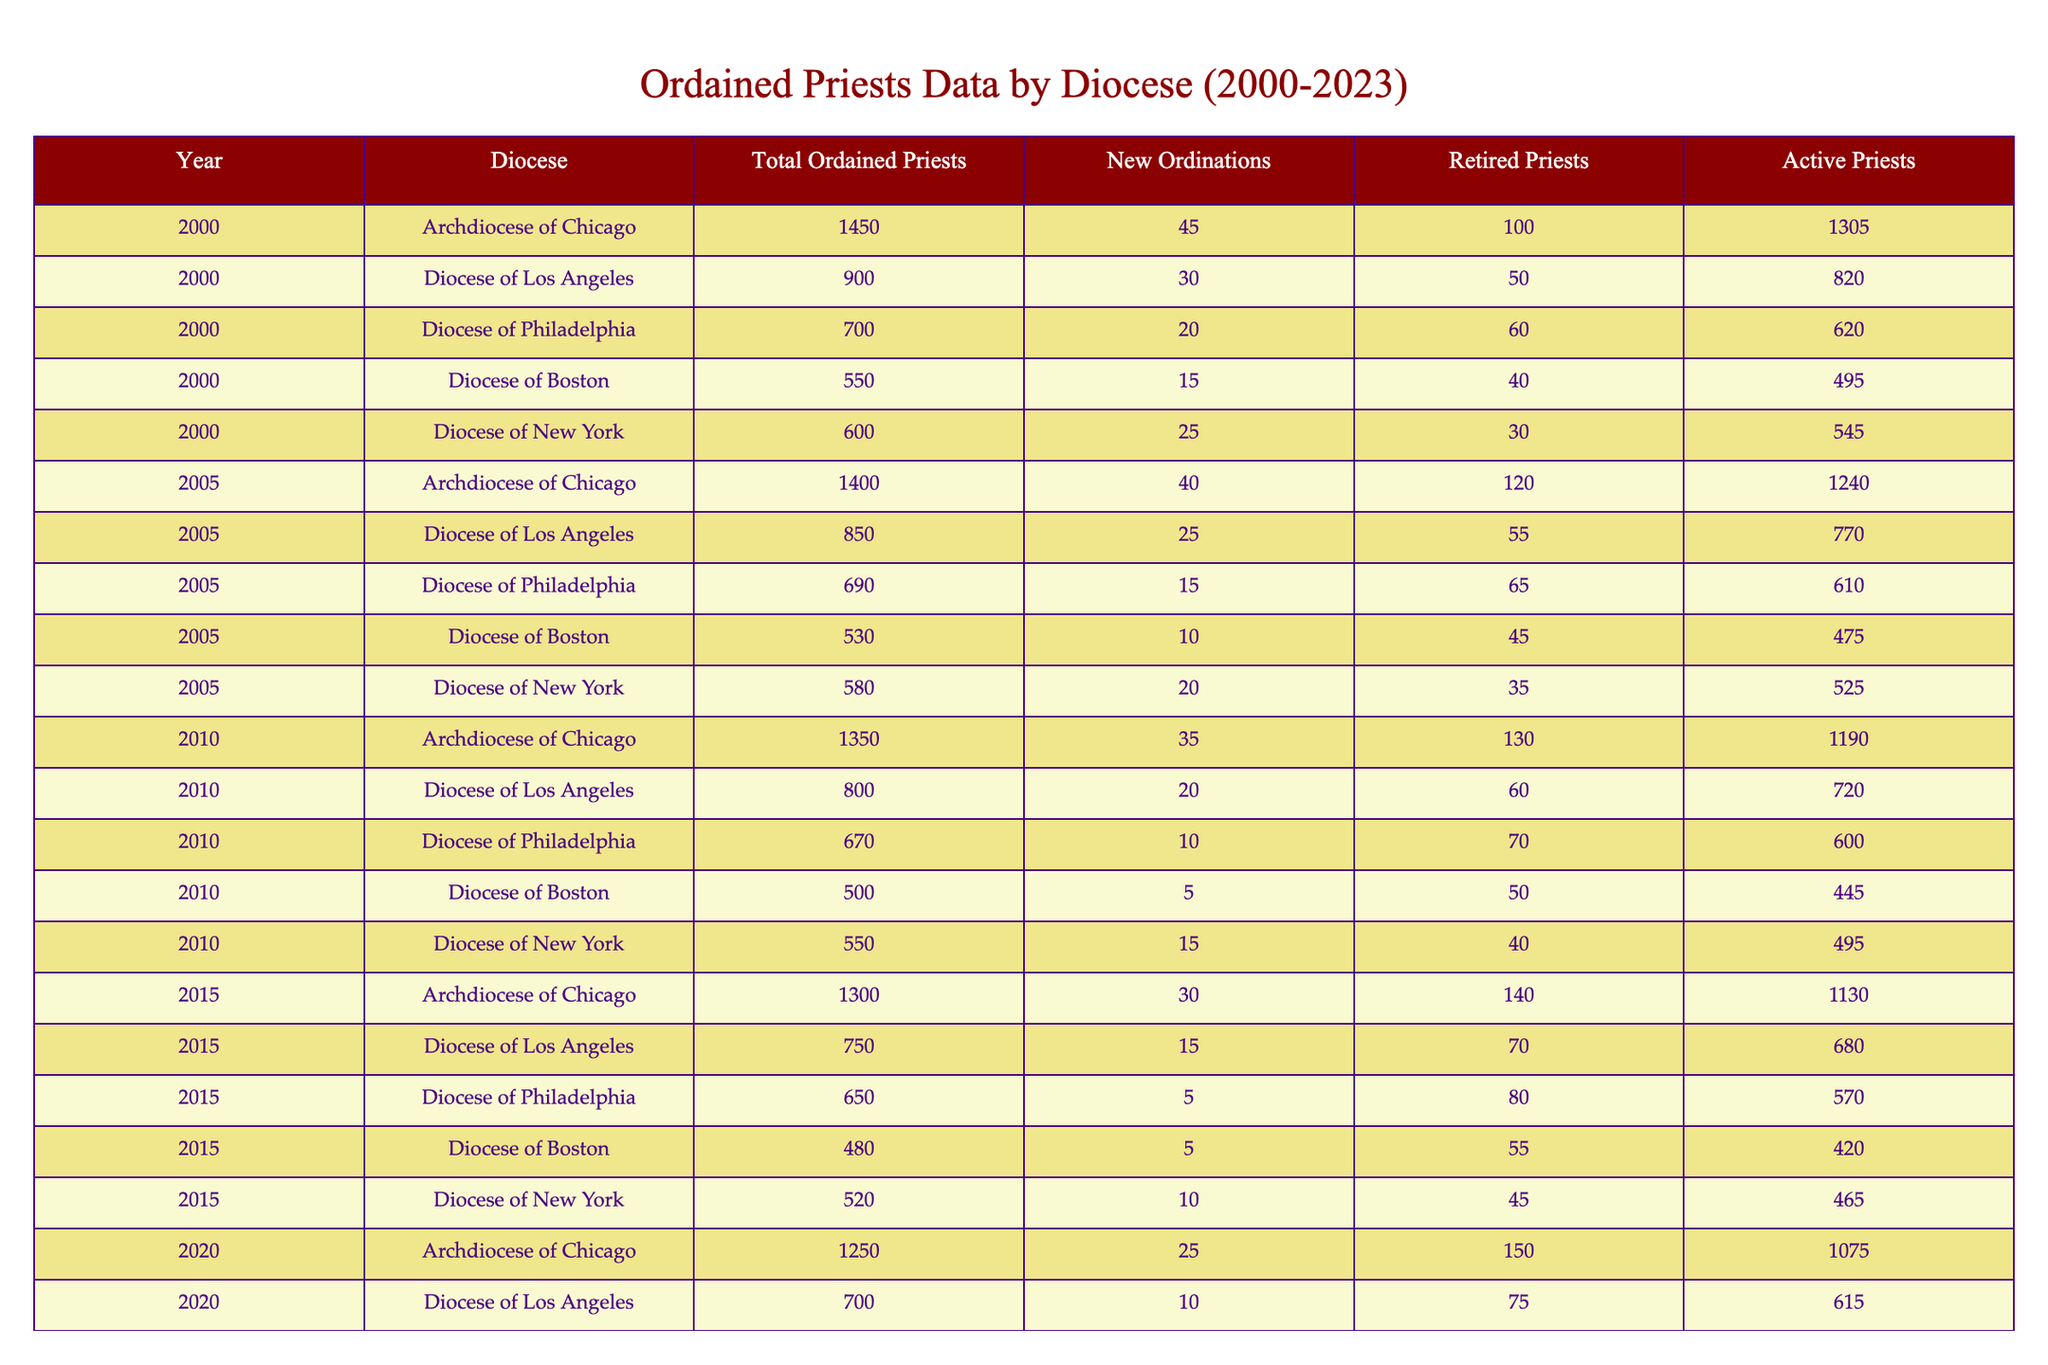What was the total number of ordained priests in the Archdiocese of Chicago in 2010? From the table, the row for the Archdiocese of Chicago in 2010 shows a value of 1350 for Total Ordained Priests.
Answer: 1350 How many new ordinations were there in the Diocese of Boston in 2023? Looking at the row for the Diocese of Boston in 2023, the value for New Ordinations is 5.
Answer: 5 Which diocese had the highest number of active priests in 2005? In 2005, the Archdiocese of Chicago had 1240 active priests, which is higher than any other diocese listed for that year.
Answer: Archdiocese of Chicago How many total ordained priests were there in the Diocese of Philadelphia by 2020? The data shows that the number of Total Ordained Priests in the Diocese of Philadelphia in 2020 was 620.
Answer: 620 What is the average number of new ordinations across all dioceses in 2015? Adding up the new ordinations for all dioceses in 2015 gives: 30 + 15 + 5 + 5 + 10 = 65. Dividing this sum by 5 (the number of dioceses) results in an average of 13.
Answer: 13 Did the number of active priests in the Diocese of New York increase from 2020 to 2023? In 2020, there were 445 active priests in the Diocese of New York, and in 2023, that number rose to 480. Therefore, the number increased.
Answer: Yes What was the total decrease in the number of ordained priests in the Archdiocese of Chicago from 2000 to 2023? The data shows that the total number of ordained priests in 2000 was 1450, and by 2023 it was 1200. The decrease is 1450 - 1200 = 250.
Answer: 250 Which diocese experienced the largest decrease in the number of total ordained priests from 2000 to 2023? By comparing the values, the Diocese of Boston decreased from 550 to 440, resulting in a decrease of 110. The Diocese of Los Angeles decreased from 900 to 650, a drop of 250, indicating it experienced the largest decrease.
Answer: Diocese of Los Angeles What percentage of priests were retired in the Diocese of Philadelphia in 2010? In 2010, the Diocese of Philadelphia had 670 ordained priests and 70 were retired. The percentage is (70 / 670) * 100 ≈ 10.45%.
Answer: Approximately 10.45% Is it true that the Diocese of Boston has consistently had fewer than 500 total ordained priests from 2010 to 2023? The table shows that in 2010 there were 500, but from 2015 to 2023 the numbers were 480, 460, and 440, meaning it dropped below 500 after 2010. Therefore, the statement is true.
Answer: Yes 